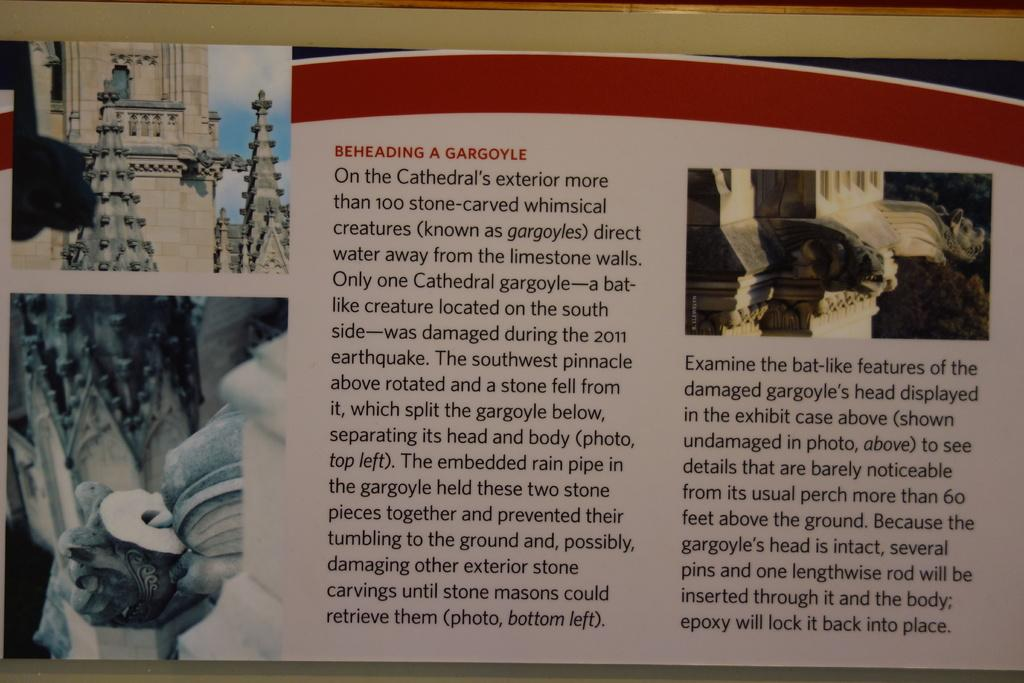<image>
Present a compact description of the photo's key features. instructions regarding on how it is to reheading a gargoyle 